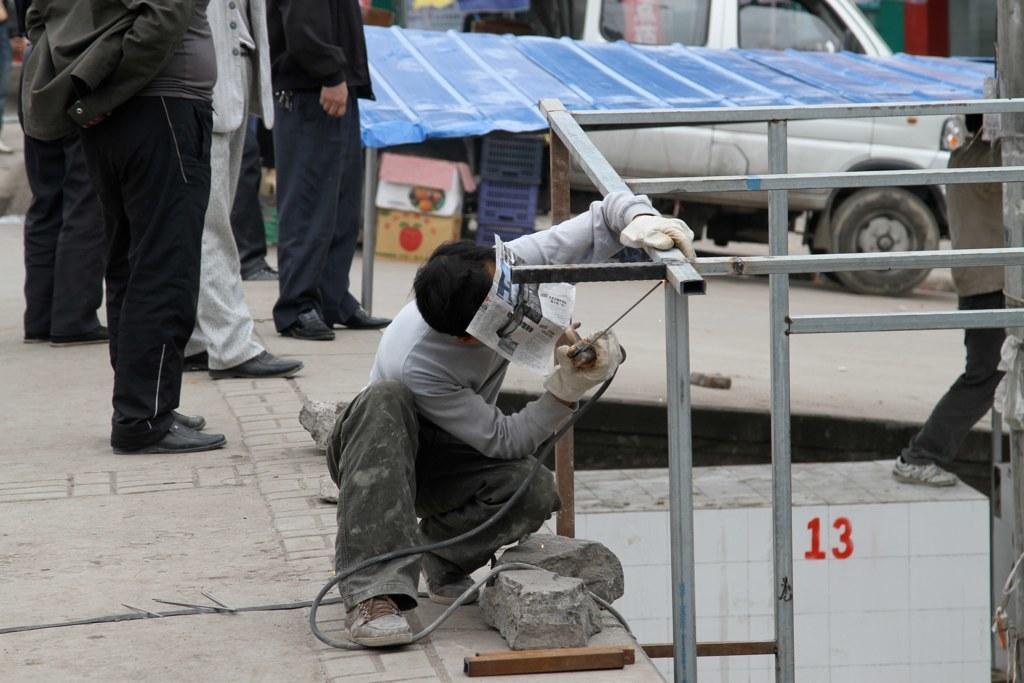Could you give a brief overview of what you see in this image? There is a person sitting like squat position and holding a tool and rod and we can see paper on this person face. We can see rods,wall and people. In the background we can see vehicle,baskets and boxes on the surface and blue metal object. 